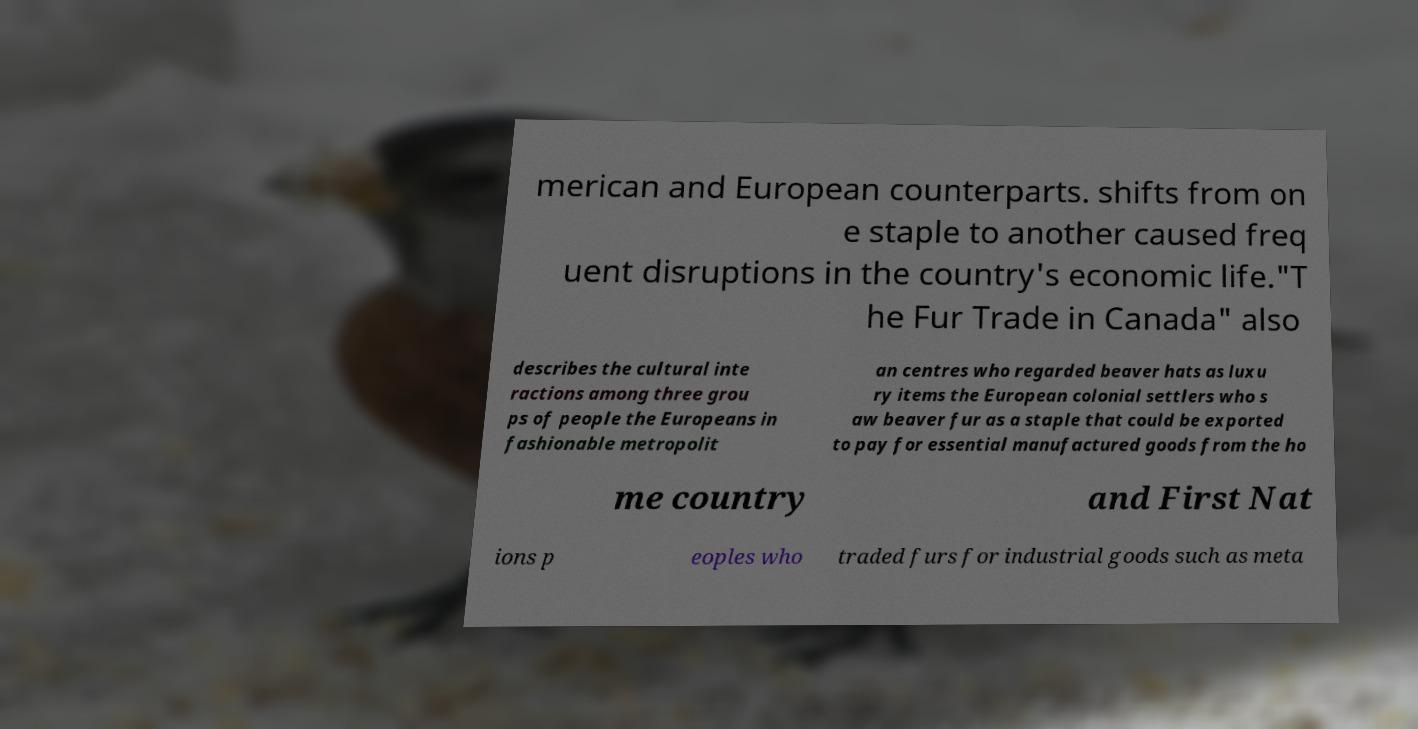There's text embedded in this image that I need extracted. Can you transcribe it verbatim? merican and European counterparts. shifts from on e staple to another caused freq uent disruptions in the country's economic life."T he Fur Trade in Canada" also describes the cultural inte ractions among three grou ps of people the Europeans in fashionable metropolit an centres who regarded beaver hats as luxu ry items the European colonial settlers who s aw beaver fur as a staple that could be exported to pay for essential manufactured goods from the ho me country and First Nat ions p eoples who traded furs for industrial goods such as meta 